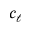<formula> <loc_0><loc_0><loc_500><loc_500>c _ { \ell }</formula> 